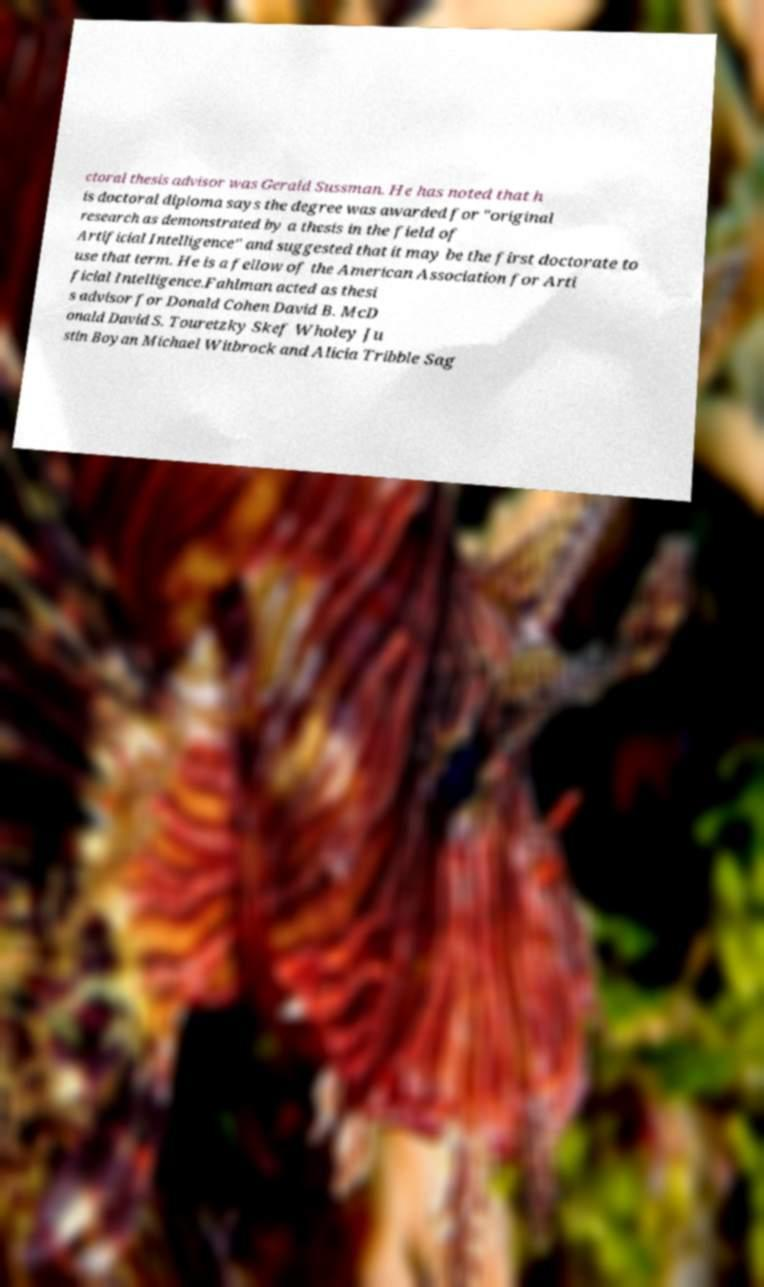There's text embedded in this image that I need extracted. Can you transcribe it verbatim? ctoral thesis advisor was Gerald Sussman. He has noted that h is doctoral diploma says the degree was awarded for "original research as demonstrated by a thesis in the field of Artificial Intelligence" and suggested that it may be the first doctorate to use that term. He is a fellow of the American Association for Arti ficial Intelligence.Fahlman acted as thesi s advisor for Donald Cohen David B. McD onald David S. Touretzky Skef Wholey Ju stin Boyan Michael Witbrock and Alicia Tribble Sag 